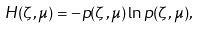<formula> <loc_0><loc_0><loc_500><loc_500>H ( \zeta , \mu ) = - p ( \zeta , \mu ) \ln p ( \zeta , \mu ) ,</formula> 